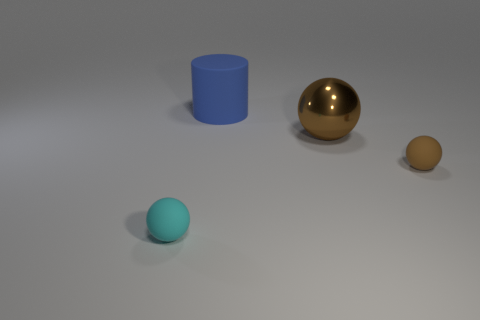There is another tiny object that is the same shape as the cyan object; what material is it?
Ensure brevity in your answer.  Rubber. What is the material of the small thing that is behind the sphere to the left of the large blue object that is right of the cyan matte thing?
Your answer should be very brief. Rubber. Are the ball left of the big sphere and the large thing that is behind the large brown metallic object made of the same material?
Provide a succinct answer. Yes. There is a thing that is both to the left of the large sphere and behind the small cyan object; how big is it?
Ensure brevity in your answer.  Large. There is another sphere that is the same size as the brown rubber sphere; what is it made of?
Your response must be concise. Rubber. There is a thing in front of the tiny object that is on the right side of the matte cylinder; what number of large blue cylinders are in front of it?
Ensure brevity in your answer.  0. There is a tiny object right of the cylinder; does it have the same color as the ball behind the tiny brown ball?
Provide a short and direct response. Yes. There is a object that is both on the left side of the big brown thing and in front of the big blue object; what is its color?
Provide a short and direct response. Cyan. How many cyan spheres are the same size as the blue matte cylinder?
Your answer should be compact. 0. What shape is the rubber object behind the tiny thing on the right side of the large blue matte thing?
Ensure brevity in your answer.  Cylinder. 